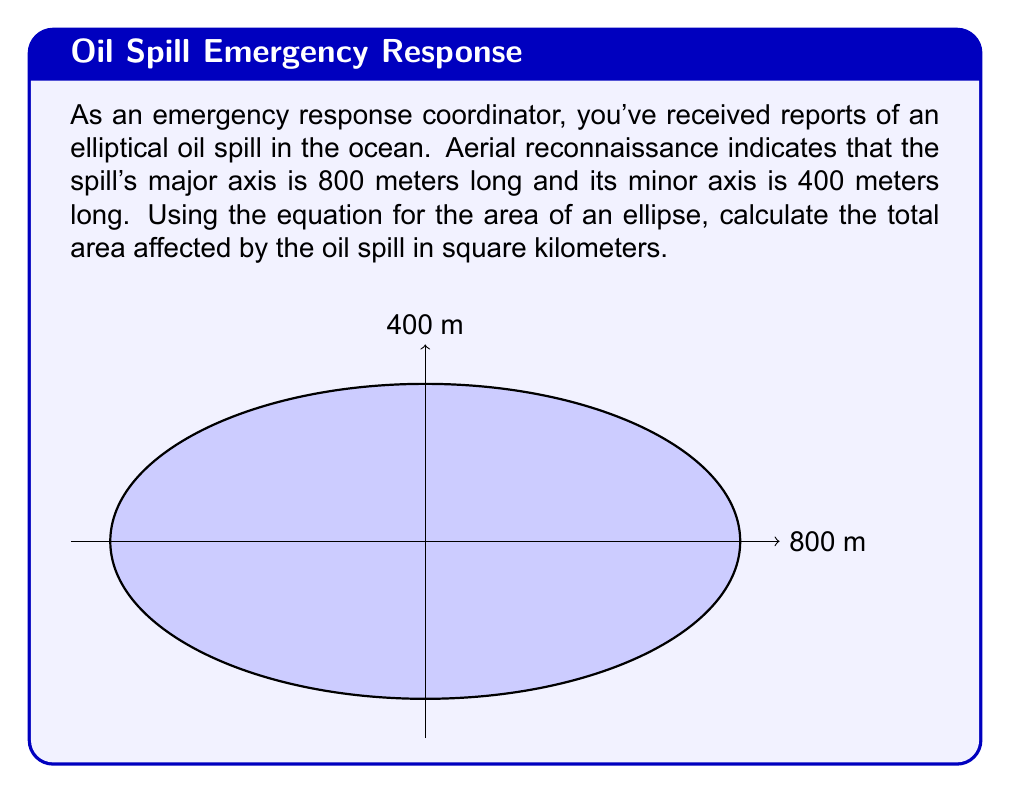Provide a solution to this math problem. To solve this problem, we'll follow these steps:

1) Recall the formula for the area of an ellipse:
   $$A = \pi ab$$
   where $a$ is half the length of the major axis and $b$ is half the length of the minor axis.

2) Identify $a$ and $b$ from the given information:
   $a = 800/2 = 400$ meters
   $b = 400/2 = 200$ meters

3) Substitute these values into the formula:
   $$A = \pi (400)(200)$$

4) Calculate:
   $$A = 80000\pi \approx 251327.41 \text{ square meters}$$

5) Convert square meters to square kilometers:
   $$251327.41 \text{ m}^2 \times \frac{1 \text{ km}^2}{1000000 \text{ m}^2} \approx 0.25133 \text{ km}^2$$

Therefore, the area affected by the oil spill is approximately 0.25133 square kilometers.
Answer: $0.25133 \text{ km}^2$ 